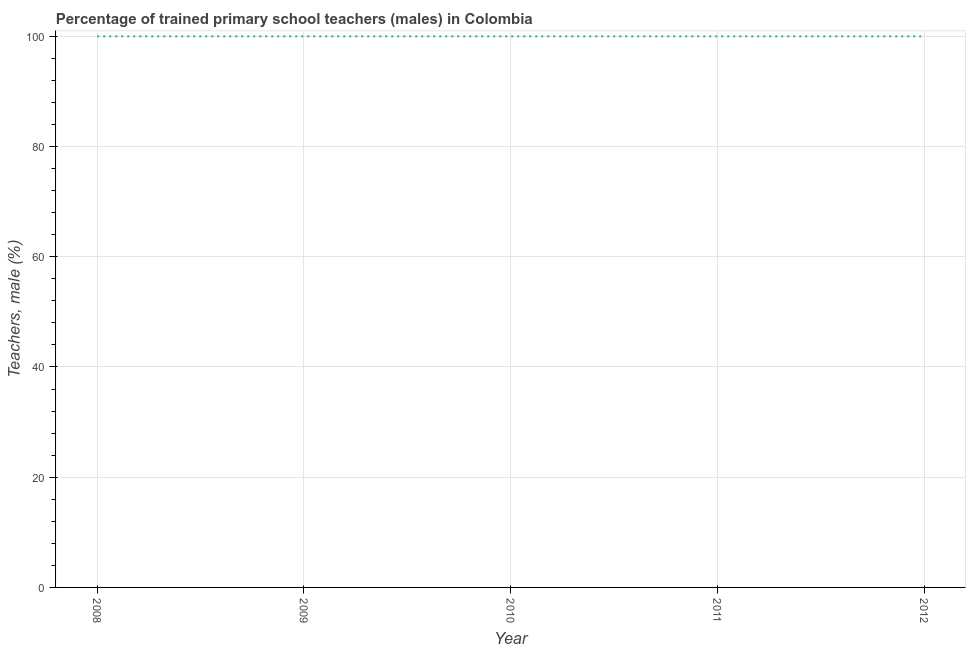Across all years, what is the maximum percentage of trained male teachers?
Make the answer very short. 100. In which year was the percentage of trained male teachers maximum?
Offer a very short reply. 2008. What is the sum of the percentage of trained male teachers?
Offer a very short reply. 500. What is the difference between the percentage of trained male teachers in 2008 and 2012?
Offer a terse response. 0. What is the average percentage of trained male teachers per year?
Offer a very short reply. 100. What is the median percentage of trained male teachers?
Your response must be concise. 100. What is the ratio of the percentage of trained male teachers in 2009 to that in 2010?
Make the answer very short. 1. Is the sum of the percentage of trained male teachers in 2010 and 2011 greater than the maximum percentage of trained male teachers across all years?
Your response must be concise. Yes. What is the difference between the highest and the lowest percentage of trained male teachers?
Your response must be concise. 0. How many lines are there?
Provide a short and direct response. 1. What is the title of the graph?
Keep it short and to the point. Percentage of trained primary school teachers (males) in Colombia. What is the label or title of the Y-axis?
Make the answer very short. Teachers, male (%). What is the Teachers, male (%) in 2008?
Provide a succinct answer. 100. What is the Teachers, male (%) of 2009?
Give a very brief answer. 100. What is the Teachers, male (%) in 2010?
Your answer should be compact. 100. What is the difference between the Teachers, male (%) in 2008 and 2009?
Offer a terse response. 0. What is the difference between the Teachers, male (%) in 2008 and 2011?
Offer a very short reply. 0. What is the difference between the Teachers, male (%) in 2009 and 2011?
Provide a short and direct response. 0. What is the difference between the Teachers, male (%) in 2010 and 2011?
Ensure brevity in your answer.  0. What is the difference between the Teachers, male (%) in 2010 and 2012?
Offer a terse response. 0. What is the ratio of the Teachers, male (%) in 2008 to that in 2009?
Give a very brief answer. 1. What is the ratio of the Teachers, male (%) in 2008 to that in 2010?
Provide a short and direct response. 1. What is the ratio of the Teachers, male (%) in 2008 to that in 2011?
Provide a succinct answer. 1. What is the ratio of the Teachers, male (%) in 2009 to that in 2011?
Offer a very short reply. 1. What is the ratio of the Teachers, male (%) in 2010 to that in 2011?
Your answer should be compact. 1. 